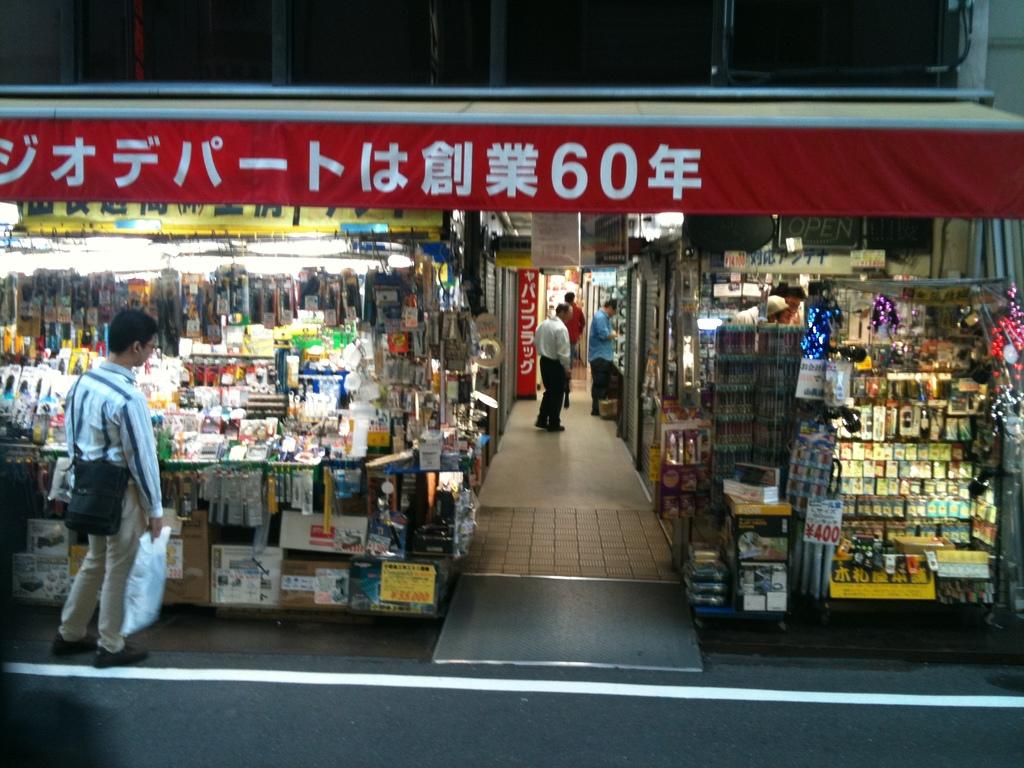What number is on the awning?
Your answer should be compact. 60. 